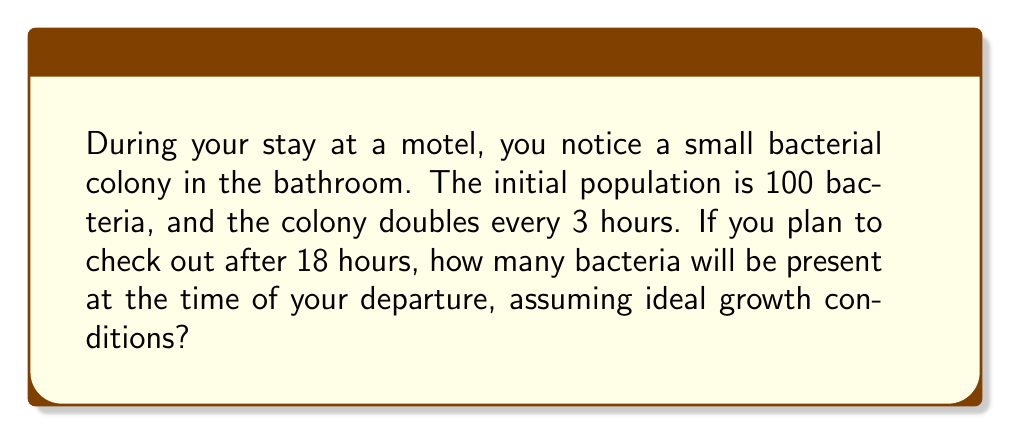Can you solve this math problem? To solve this problem, we need to use the concept of exponential growth. The bacterial population grows by a factor of 2 every 3 hours, which means we can use the following equation:

$$N(t) = N_0 \cdot 2^{\frac{t}{3}}$$

Where:
$N(t)$ is the number of bacteria at time $t$ (in hours)
$N_0$ is the initial number of bacteria
$t$ is the time elapsed in hours

Given:
$N_0 = 100$ bacteria
$t = 18$ hours

Let's substitute these values into our equation:

$$N(18) = 100 \cdot 2^{\frac{18}{3}}$$

Simplify the exponent:
$$N(18) = 100 \cdot 2^6$$

Calculate $2^6$:
$$N(18) = 100 \cdot 64$$

Multiply:
$$N(18) = 6400$$

Therefore, after 18 hours, there will be 6400 bacteria in the colony.
Answer: 6400 bacteria 